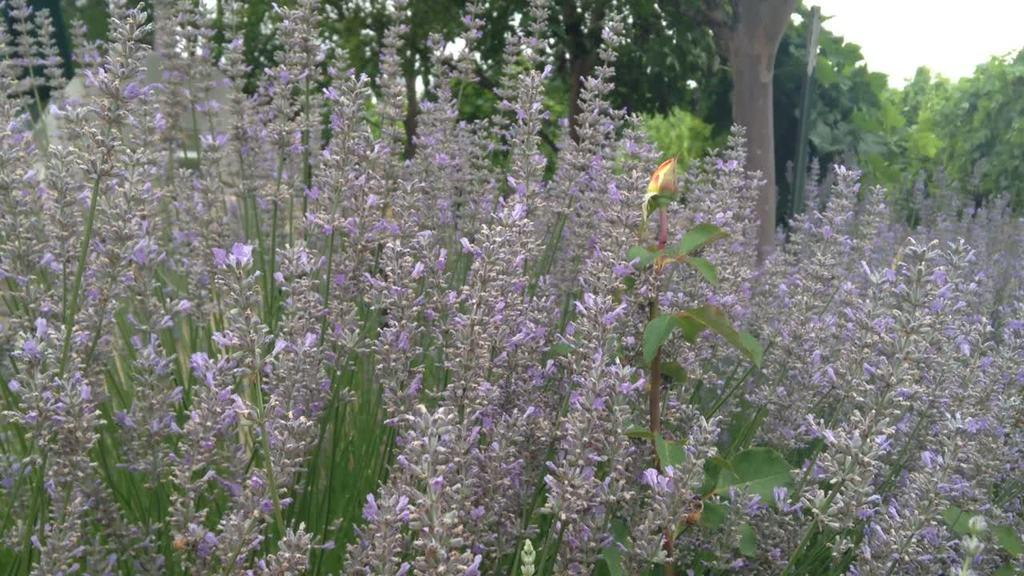What type of plants can be seen in the image? There are flower plants in the image. What can be seen in the background of the image? There are trees in the background of the image. What type of jail can be seen in the image? There is no jail present in the image; it features flower plants and trees. What type of vegetable is growing in the image? There is no vegetable growing in the image; it features flower plants and trees. 